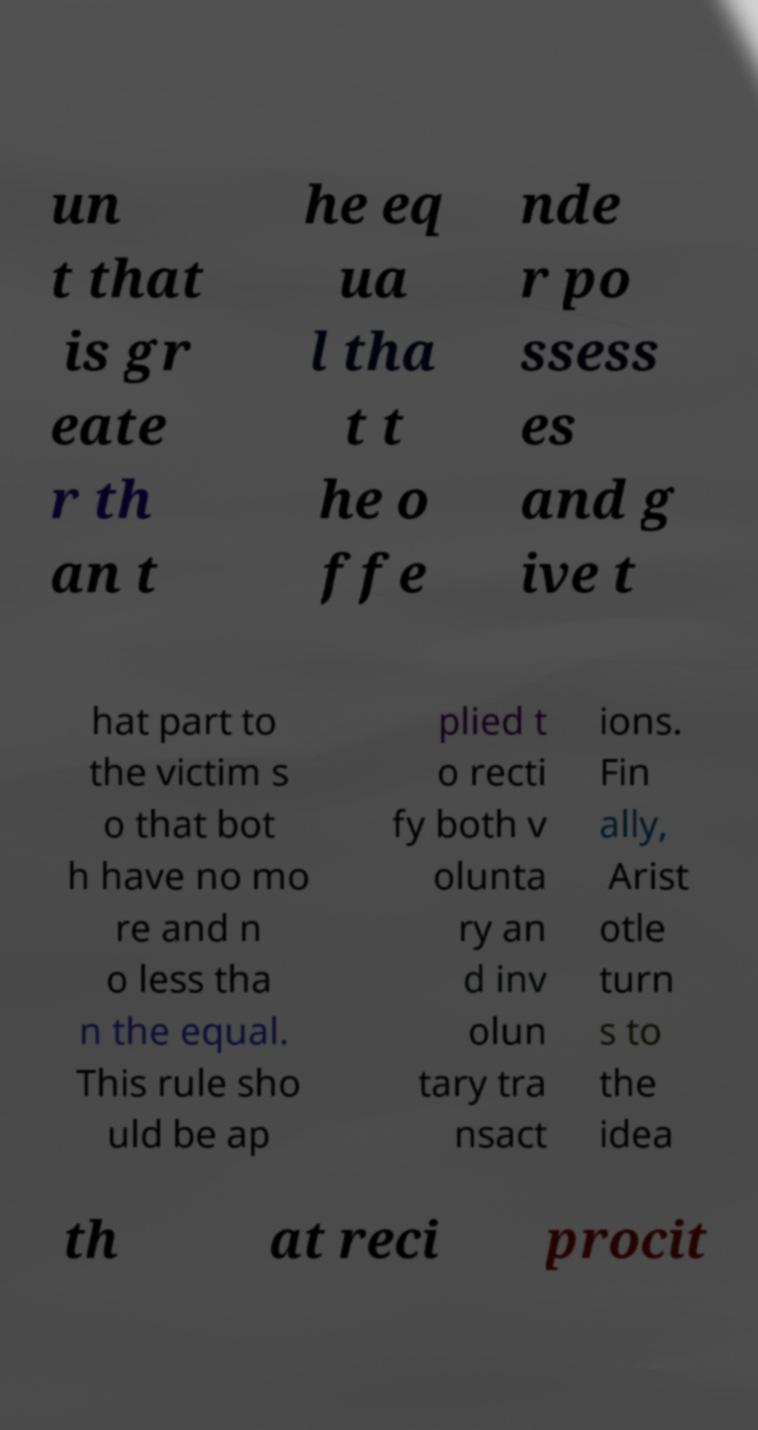Could you assist in decoding the text presented in this image and type it out clearly? un t that is gr eate r th an t he eq ua l tha t t he o ffe nde r po ssess es and g ive t hat part to the victim s o that bot h have no mo re and n o less tha n the equal. This rule sho uld be ap plied t o recti fy both v olunta ry an d inv olun tary tra nsact ions. Fin ally, Arist otle turn s to the idea th at reci procit 